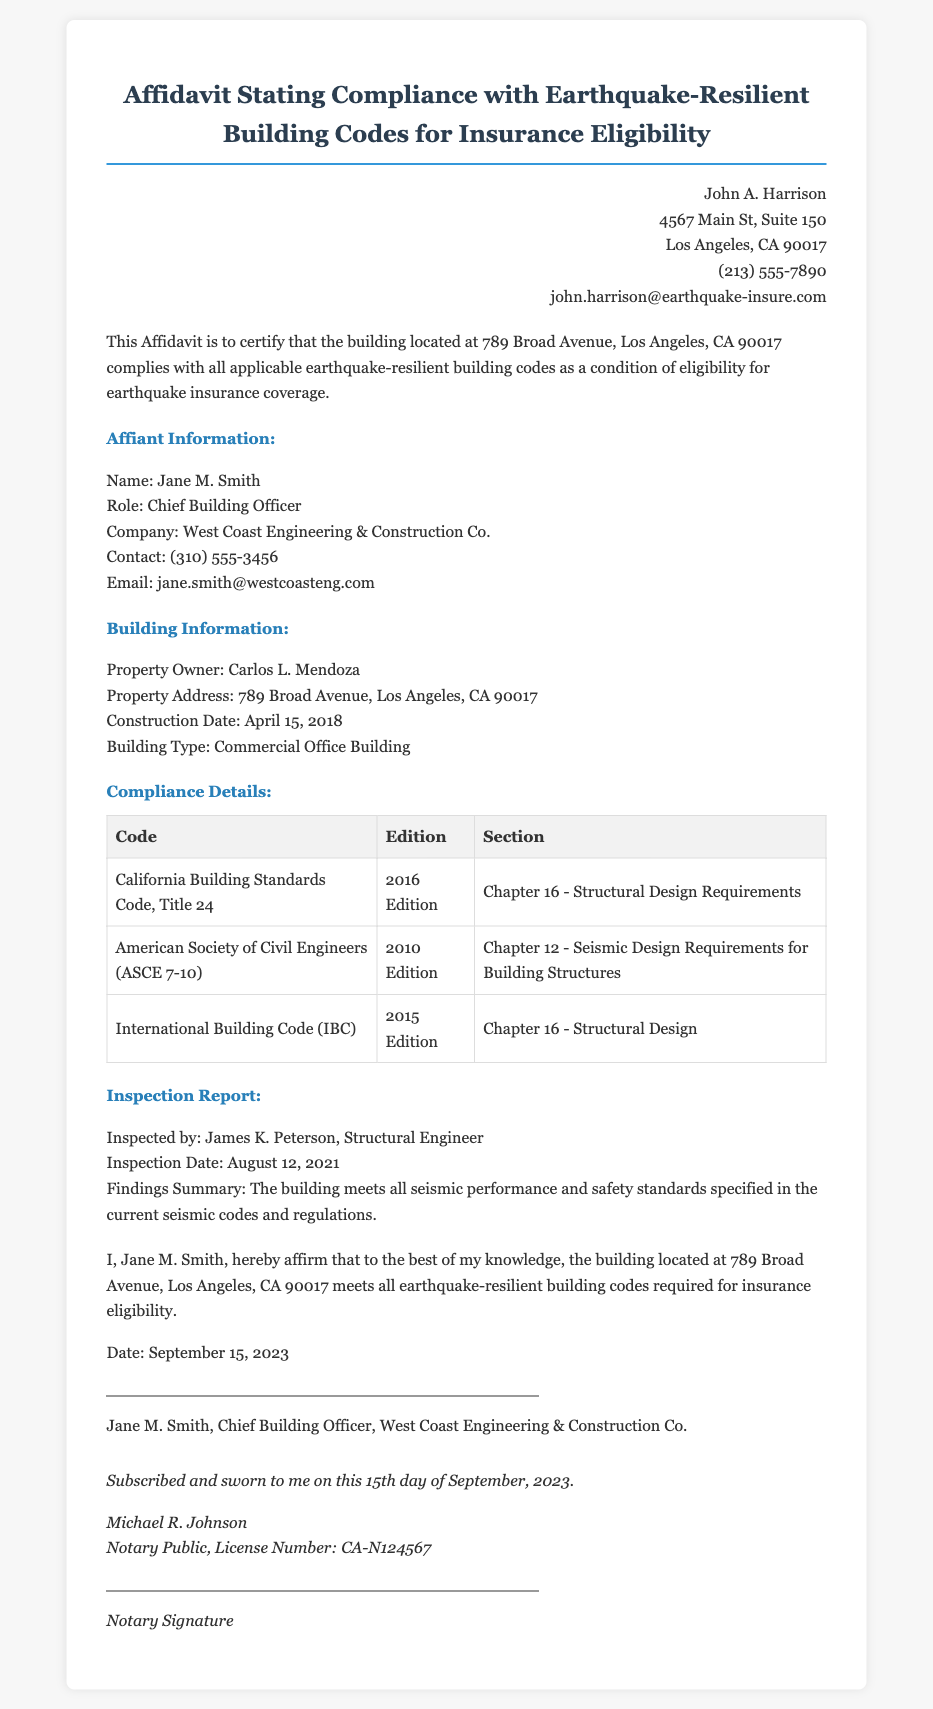What is the name of the property owner? The property owner is mentioned in the document under "Building Information" as Carlos L. Mendoza.
Answer: Carlos L. Mendoza What is the construction date of the building? The construction date is listed in the "Building Information" section as April 15, 2018.
Answer: April 15, 2018 Which company is the affiant associated with? The affiant's association is stated in the "Affiant Information" section as West Coast Engineering & Construction Co.
Answer: West Coast Engineering & Construction Co What type of building is being documented? This information is specified in the "Building Information" section where the type of building is identified as a Commercial Office Building.
Answer: Commercial Office Building Who inspected the building? The inspector's name is provided in the "Inspection Report" section as James K. Peterson.
Answer: James K. Peterson What is the license number of the notary public? The license number is mentioned in the notary section at the end of the document as CA-N124567.
Answer: CA-N124567 What regulation code requires structural design compliance? The compliance details section lists California Building Standards Code, Title 24 as a required regulation.
Answer: California Building Standards Code, Title 24 What date was the inspection conducted? The date is found in the "Inspection Report" section, recorded as August 12, 2021.
Answer: August 12, 2021 Which email address is associated with the affiant? The email address is located in the "Affiant Information" section as jane.smith@westcoasteng.com.
Answer: jane.smith@westcoasteng.com 